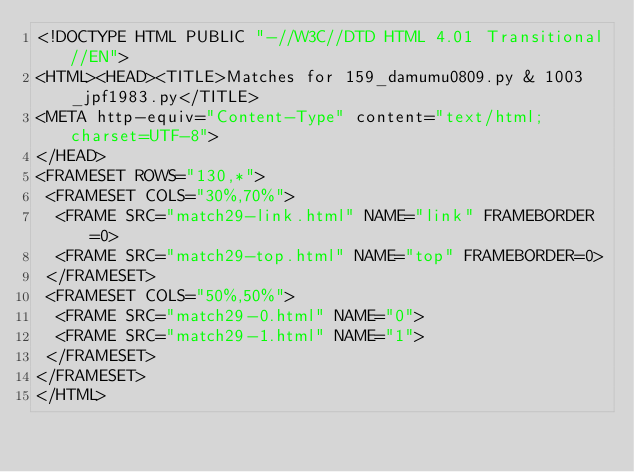<code> <loc_0><loc_0><loc_500><loc_500><_HTML_><!DOCTYPE HTML PUBLIC "-//W3C//DTD HTML 4.01 Transitional//EN">
<HTML><HEAD><TITLE>Matches for 159_damumu0809.py & 1003_jpf1983.py</TITLE>
<META http-equiv="Content-Type" content="text/html; charset=UTF-8">
</HEAD>
<FRAMESET ROWS="130,*">
 <FRAMESET COLS="30%,70%">
  <FRAME SRC="match29-link.html" NAME="link" FRAMEBORDER=0>
  <FRAME SRC="match29-top.html" NAME="top" FRAMEBORDER=0>
 </FRAMESET>
 <FRAMESET COLS="50%,50%">
  <FRAME SRC="match29-0.html" NAME="0">
  <FRAME SRC="match29-1.html" NAME="1">
 </FRAMESET>
</FRAMESET>
</HTML>
</code> 